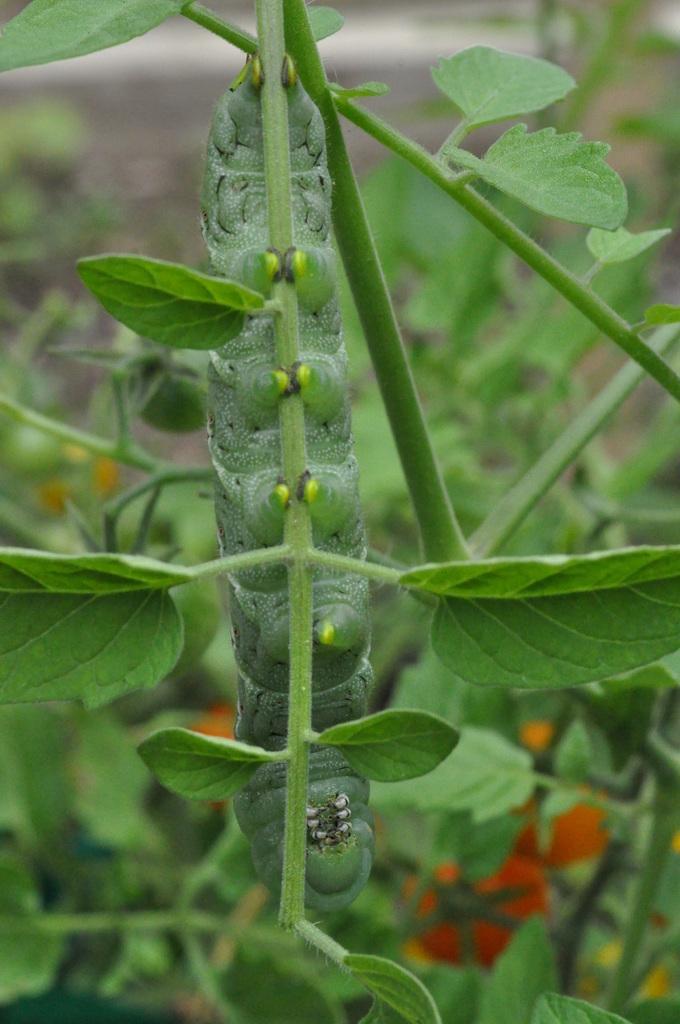Please provide a concise description of this image. In this picture I can see the plants. In the background I can see the blur image. In the bottom right I can see the red tomatoes on the plant. On the left I can see some green tomatoes. 